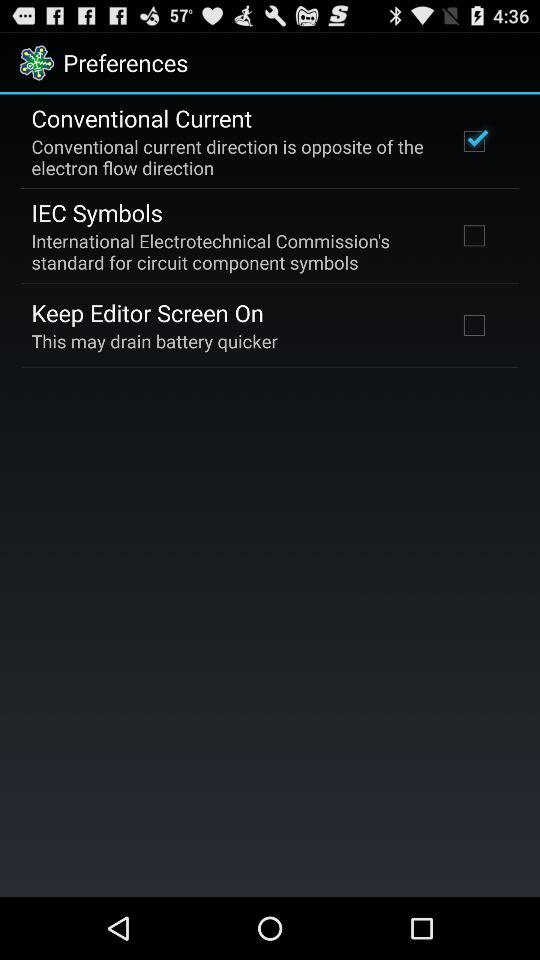Which flow direction is opposite of the conventional current direction? The conventional current direction is opposite of the electron flow direction. 